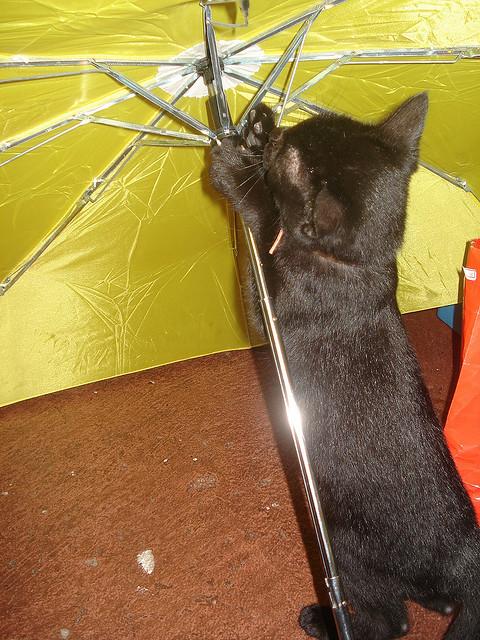Who plays with the umbrella?
Short answer required. Cat. Is the cat holding the umbrella?
Be succinct. Yes. Is the cat a tabby?
Keep it brief. No. What color is the umbrella?
Answer briefly. Yellow. What color is the cat?
Write a very short answer. Black. What is the surface of the floor made of?
Quick response, please. Carpet. 